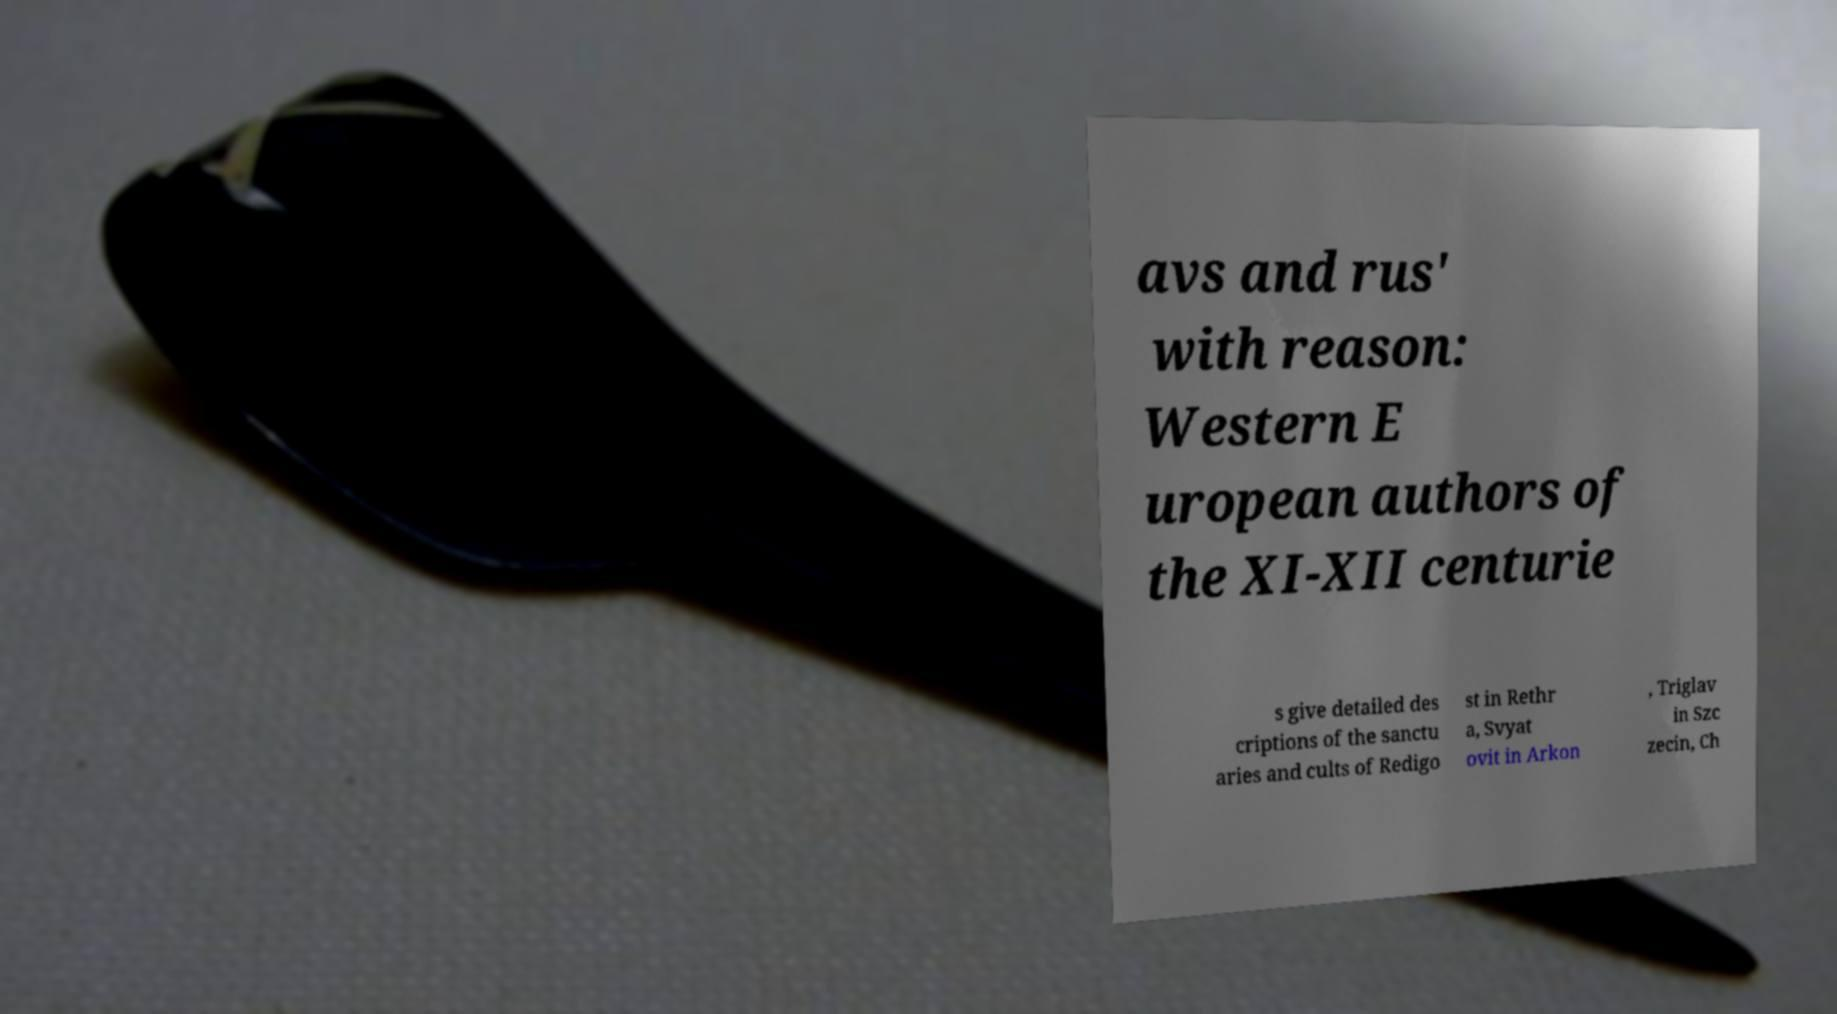There's text embedded in this image that I need extracted. Can you transcribe it verbatim? avs and rus' with reason: Western E uropean authors of the XI-XII centurie s give detailed des criptions of the sanctu aries and cults of Redigo st in Rethr a, Svyat ovit in Arkon , Triglav in Szc zecin, Ch 